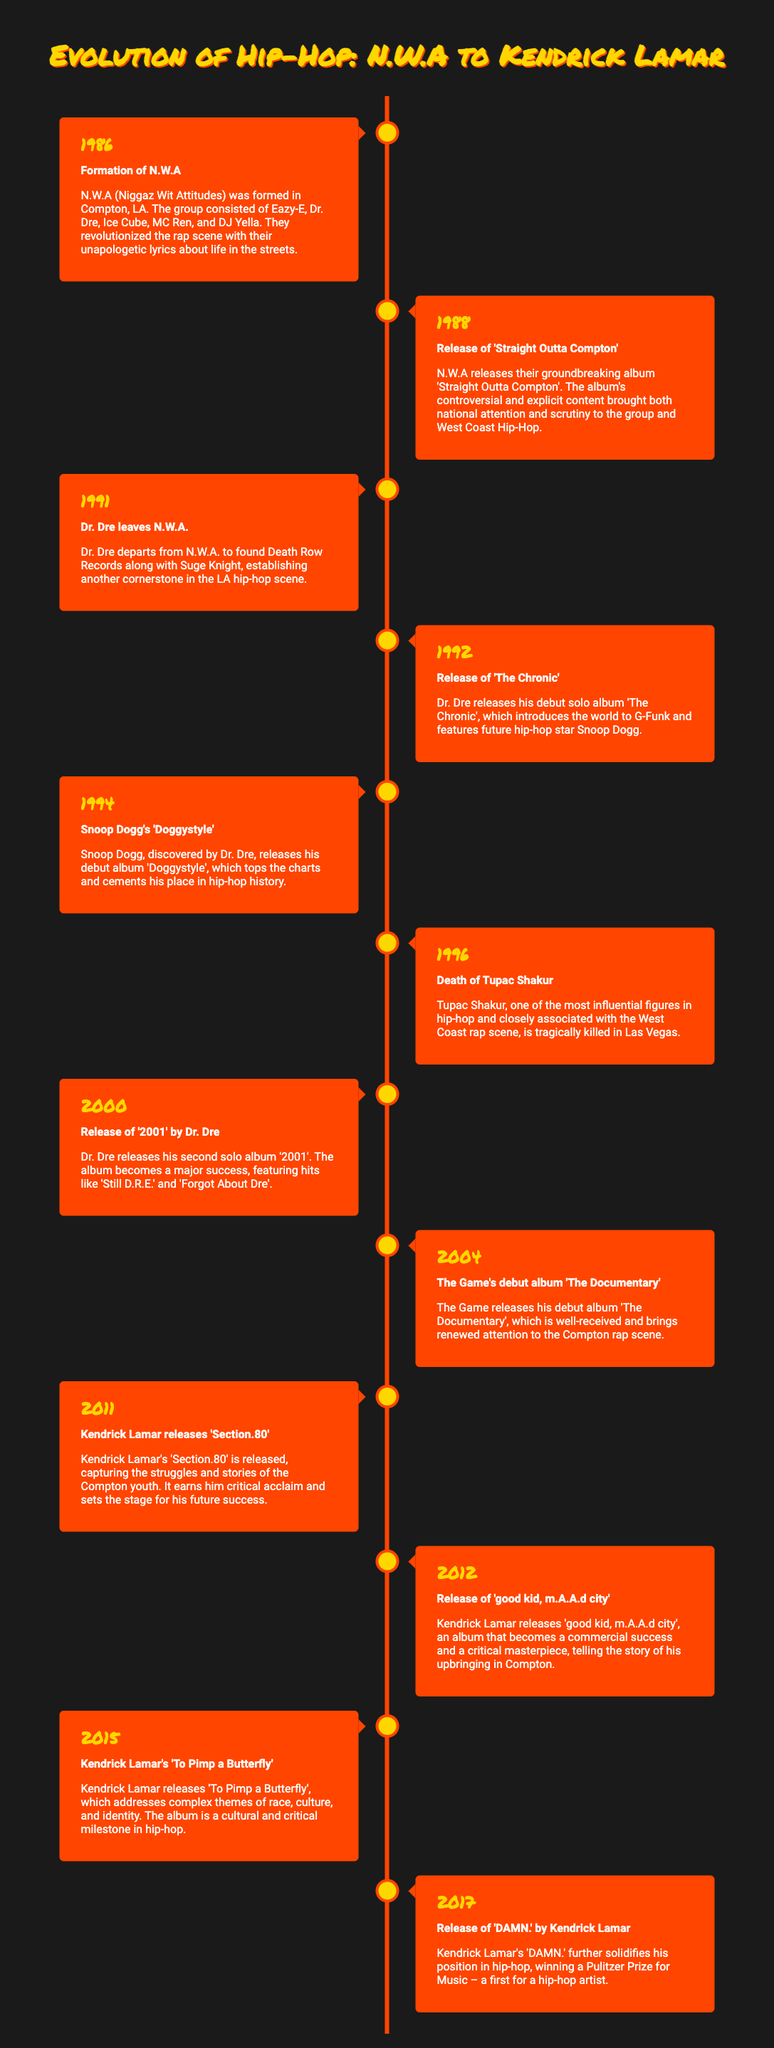What year was N.W.A formed? The document states that N.W.A was formed in the year 1986.
Answer: 1986 Who released 'The Chronic'? Dr. Dre is indicated as the artist who released 'The Chronic' in 1992.
Answer: Dr. Dre What significant event happened in 1996? The document states that Tupac Shakur died in 1996.
Answer: Death of Tupac Shakur How many albums did Kendrick Lamar release between 2011 and 2017? The timeline lists three albums released by Kendrick Lamar in that period: 'Section.80', 'good kid, m.A.A.d city', and 'To Pimp a Butterfly'.
Answer: Three What milestone is associated with Kendrick Lamar's 'DAMN.'? The document highlights that 'DAMN.' won a Pulitzer Prize for Music in 2017.
Answer: Pulitzer Prize In what year did Snoop Dogg release his debut album 'Doggystyle'? The release year of Snoop Dogg's debut album 'Doggystyle' is mentioned as 1994.
Answer: 1994 How did N.W.A impact West Coast Hip-Hop? According to the document, N.W.A brought both national attention and scrutiny to West Coast Hip-Hop.
Answer: National attention and scrutiny What does the timeline track? The timeline tracks significant milestones in LA Hip-Hop history from N.W.A to Kendrick Lamar.
Answer: Milestones in LA Hip-Hop history 